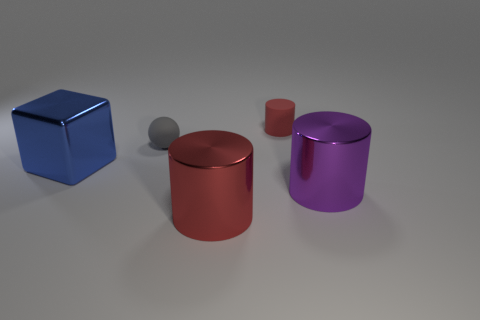Do the matte thing that is behind the tiny gray matte thing and the large purple shiny thing have the same shape?
Offer a terse response. Yes. Are there more red metallic cylinders in front of the small cylinder than blue matte objects?
Your answer should be compact. Yes. What number of objects are to the left of the tiny matte cylinder and behind the large purple shiny object?
Make the answer very short. 2. What is the color of the small object to the right of the red thing in front of the purple thing?
Your response must be concise. Red. What number of small spheres are the same color as the large metallic block?
Ensure brevity in your answer.  0. There is a small cylinder; is its color the same as the big cylinder left of the large purple shiny cylinder?
Offer a terse response. Yes. Are there fewer tiny yellow metal cubes than cylinders?
Keep it short and to the point. Yes. Are there more big metallic objects that are to the right of the big red metal thing than tiny red things left of the gray rubber thing?
Your response must be concise. Yes. Does the tiny gray sphere have the same material as the small cylinder?
Offer a terse response. Yes. There is a red object in front of the small gray matte ball; how many large metallic cylinders are in front of it?
Give a very brief answer. 0. 